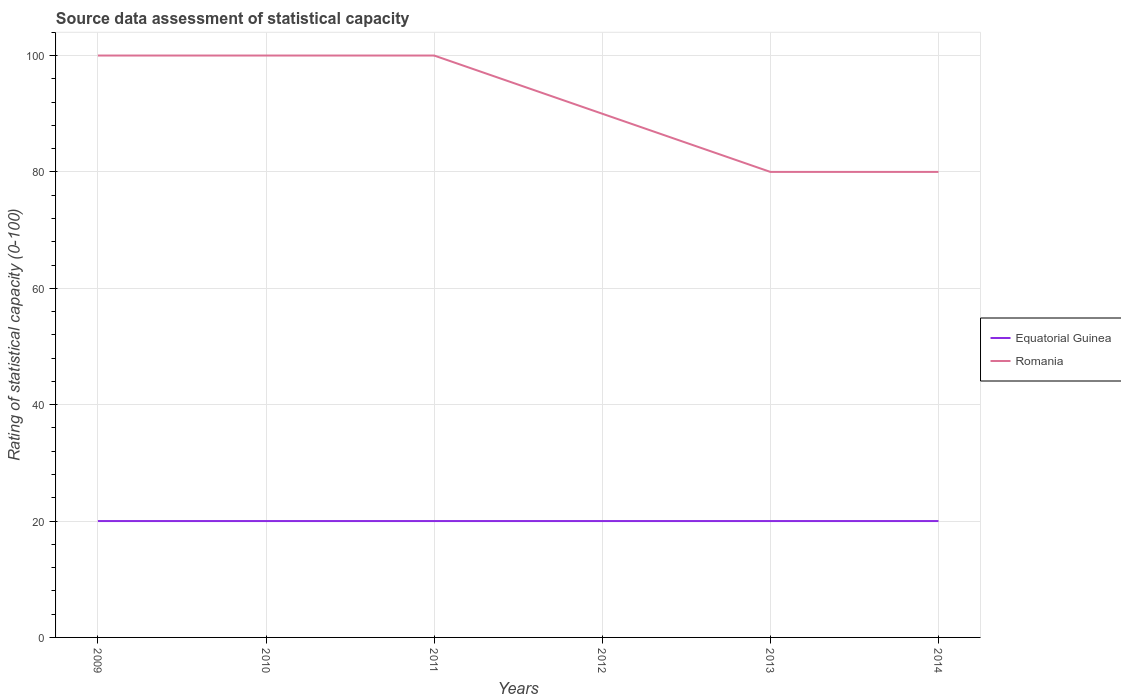How many different coloured lines are there?
Keep it short and to the point. 2. Does the line corresponding to Equatorial Guinea intersect with the line corresponding to Romania?
Your answer should be very brief. No. Is the number of lines equal to the number of legend labels?
Keep it short and to the point. Yes. Across all years, what is the maximum rating of statistical capacity in Romania?
Your response must be concise. 80. In which year was the rating of statistical capacity in Romania maximum?
Provide a succinct answer. 2013. What is the total rating of statistical capacity in Equatorial Guinea in the graph?
Provide a succinct answer. 0. What is the difference between the highest and the second highest rating of statistical capacity in Equatorial Guinea?
Offer a very short reply. 0. How many lines are there?
Provide a succinct answer. 2. What is the difference between two consecutive major ticks on the Y-axis?
Offer a very short reply. 20. Does the graph contain grids?
Offer a very short reply. Yes. Where does the legend appear in the graph?
Offer a terse response. Center right. How are the legend labels stacked?
Offer a terse response. Vertical. What is the title of the graph?
Your response must be concise. Source data assessment of statistical capacity. What is the label or title of the X-axis?
Provide a short and direct response. Years. What is the label or title of the Y-axis?
Give a very brief answer. Rating of statistical capacity (0-100). What is the Rating of statistical capacity (0-100) of Romania in 2009?
Provide a short and direct response. 100. What is the Rating of statistical capacity (0-100) in Equatorial Guinea in 2010?
Your answer should be very brief. 20. What is the Rating of statistical capacity (0-100) of Romania in 2010?
Your response must be concise. 100. What is the Rating of statistical capacity (0-100) of Equatorial Guinea in 2011?
Make the answer very short. 20. What is the Rating of statistical capacity (0-100) in Romania in 2011?
Your answer should be very brief. 100. What is the Rating of statistical capacity (0-100) in Equatorial Guinea in 2014?
Give a very brief answer. 20. What is the total Rating of statistical capacity (0-100) in Equatorial Guinea in the graph?
Offer a terse response. 120. What is the total Rating of statistical capacity (0-100) in Romania in the graph?
Provide a short and direct response. 550. What is the difference between the Rating of statistical capacity (0-100) of Equatorial Guinea in 2009 and that in 2010?
Provide a succinct answer. 0. What is the difference between the Rating of statistical capacity (0-100) of Romania in 2009 and that in 2010?
Provide a short and direct response. 0. What is the difference between the Rating of statistical capacity (0-100) in Equatorial Guinea in 2009 and that in 2013?
Give a very brief answer. 0. What is the difference between the Rating of statistical capacity (0-100) in Romania in 2009 and that in 2013?
Your response must be concise. 20. What is the difference between the Rating of statistical capacity (0-100) of Romania in 2009 and that in 2014?
Offer a very short reply. 20. What is the difference between the Rating of statistical capacity (0-100) of Equatorial Guinea in 2010 and that in 2011?
Make the answer very short. 0. What is the difference between the Rating of statistical capacity (0-100) in Romania in 2010 and that in 2012?
Provide a succinct answer. 10. What is the difference between the Rating of statistical capacity (0-100) of Equatorial Guinea in 2010 and that in 2013?
Your answer should be compact. 0. What is the difference between the Rating of statistical capacity (0-100) of Romania in 2010 and that in 2014?
Keep it short and to the point. 20. What is the difference between the Rating of statistical capacity (0-100) of Equatorial Guinea in 2011 and that in 2012?
Your answer should be very brief. 0. What is the difference between the Rating of statistical capacity (0-100) in Romania in 2011 and that in 2012?
Your answer should be compact. 10. What is the difference between the Rating of statistical capacity (0-100) in Equatorial Guinea in 2011 and that in 2014?
Offer a terse response. 0. What is the difference between the Rating of statistical capacity (0-100) in Equatorial Guinea in 2012 and that in 2013?
Provide a short and direct response. 0. What is the difference between the Rating of statistical capacity (0-100) in Romania in 2013 and that in 2014?
Offer a very short reply. 0. What is the difference between the Rating of statistical capacity (0-100) of Equatorial Guinea in 2009 and the Rating of statistical capacity (0-100) of Romania in 2010?
Offer a very short reply. -80. What is the difference between the Rating of statistical capacity (0-100) of Equatorial Guinea in 2009 and the Rating of statistical capacity (0-100) of Romania in 2011?
Your response must be concise. -80. What is the difference between the Rating of statistical capacity (0-100) in Equatorial Guinea in 2009 and the Rating of statistical capacity (0-100) in Romania in 2012?
Offer a very short reply. -70. What is the difference between the Rating of statistical capacity (0-100) in Equatorial Guinea in 2009 and the Rating of statistical capacity (0-100) in Romania in 2013?
Give a very brief answer. -60. What is the difference between the Rating of statistical capacity (0-100) of Equatorial Guinea in 2009 and the Rating of statistical capacity (0-100) of Romania in 2014?
Give a very brief answer. -60. What is the difference between the Rating of statistical capacity (0-100) of Equatorial Guinea in 2010 and the Rating of statistical capacity (0-100) of Romania in 2011?
Provide a succinct answer. -80. What is the difference between the Rating of statistical capacity (0-100) in Equatorial Guinea in 2010 and the Rating of statistical capacity (0-100) in Romania in 2012?
Your answer should be compact. -70. What is the difference between the Rating of statistical capacity (0-100) of Equatorial Guinea in 2010 and the Rating of statistical capacity (0-100) of Romania in 2013?
Offer a terse response. -60. What is the difference between the Rating of statistical capacity (0-100) in Equatorial Guinea in 2010 and the Rating of statistical capacity (0-100) in Romania in 2014?
Offer a terse response. -60. What is the difference between the Rating of statistical capacity (0-100) of Equatorial Guinea in 2011 and the Rating of statistical capacity (0-100) of Romania in 2012?
Provide a short and direct response. -70. What is the difference between the Rating of statistical capacity (0-100) of Equatorial Guinea in 2011 and the Rating of statistical capacity (0-100) of Romania in 2013?
Your answer should be very brief. -60. What is the difference between the Rating of statistical capacity (0-100) in Equatorial Guinea in 2011 and the Rating of statistical capacity (0-100) in Romania in 2014?
Ensure brevity in your answer.  -60. What is the difference between the Rating of statistical capacity (0-100) of Equatorial Guinea in 2012 and the Rating of statistical capacity (0-100) of Romania in 2013?
Provide a succinct answer. -60. What is the difference between the Rating of statistical capacity (0-100) in Equatorial Guinea in 2012 and the Rating of statistical capacity (0-100) in Romania in 2014?
Keep it short and to the point. -60. What is the difference between the Rating of statistical capacity (0-100) in Equatorial Guinea in 2013 and the Rating of statistical capacity (0-100) in Romania in 2014?
Offer a very short reply. -60. What is the average Rating of statistical capacity (0-100) in Romania per year?
Offer a very short reply. 91.67. In the year 2009, what is the difference between the Rating of statistical capacity (0-100) of Equatorial Guinea and Rating of statistical capacity (0-100) of Romania?
Offer a terse response. -80. In the year 2010, what is the difference between the Rating of statistical capacity (0-100) in Equatorial Guinea and Rating of statistical capacity (0-100) in Romania?
Keep it short and to the point. -80. In the year 2011, what is the difference between the Rating of statistical capacity (0-100) of Equatorial Guinea and Rating of statistical capacity (0-100) of Romania?
Provide a succinct answer. -80. In the year 2012, what is the difference between the Rating of statistical capacity (0-100) of Equatorial Guinea and Rating of statistical capacity (0-100) of Romania?
Provide a short and direct response. -70. In the year 2013, what is the difference between the Rating of statistical capacity (0-100) of Equatorial Guinea and Rating of statistical capacity (0-100) of Romania?
Make the answer very short. -60. In the year 2014, what is the difference between the Rating of statistical capacity (0-100) in Equatorial Guinea and Rating of statistical capacity (0-100) in Romania?
Your answer should be very brief. -60. What is the ratio of the Rating of statistical capacity (0-100) of Equatorial Guinea in 2009 to that in 2010?
Give a very brief answer. 1. What is the ratio of the Rating of statistical capacity (0-100) of Equatorial Guinea in 2009 to that in 2011?
Ensure brevity in your answer.  1. What is the ratio of the Rating of statistical capacity (0-100) in Romania in 2009 to that in 2011?
Provide a short and direct response. 1. What is the ratio of the Rating of statistical capacity (0-100) in Romania in 2009 to that in 2012?
Ensure brevity in your answer.  1.11. What is the ratio of the Rating of statistical capacity (0-100) of Romania in 2009 to that in 2013?
Make the answer very short. 1.25. What is the ratio of the Rating of statistical capacity (0-100) in Romania in 2009 to that in 2014?
Provide a short and direct response. 1.25. What is the ratio of the Rating of statistical capacity (0-100) of Romania in 2010 to that in 2011?
Offer a very short reply. 1. What is the ratio of the Rating of statistical capacity (0-100) in Equatorial Guinea in 2010 to that in 2013?
Give a very brief answer. 1. What is the ratio of the Rating of statistical capacity (0-100) in Romania in 2011 to that in 2012?
Offer a very short reply. 1.11. What is the ratio of the Rating of statistical capacity (0-100) in Romania in 2011 to that in 2013?
Provide a short and direct response. 1.25. What is the ratio of the Rating of statistical capacity (0-100) in Equatorial Guinea in 2011 to that in 2014?
Ensure brevity in your answer.  1. What is the ratio of the Rating of statistical capacity (0-100) of Romania in 2011 to that in 2014?
Provide a short and direct response. 1.25. What is the ratio of the Rating of statistical capacity (0-100) in Romania in 2012 to that in 2014?
Make the answer very short. 1.12. What is the ratio of the Rating of statistical capacity (0-100) of Equatorial Guinea in 2013 to that in 2014?
Provide a succinct answer. 1. What is the difference between the highest and the second highest Rating of statistical capacity (0-100) of Equatorial Guinea?
Your answer should be compact. 0. What is the difference between the highest and the second highest Rating of statistical capacity (0-100) in Romania?
Give a very brief answer. 0. What is the difference between the highest and the lowest Rating of statistical capacity (0-100) in Equatorial Guinea?
Offer a very short reply. 0. What is the difference between the highest and the lowest Rating of statistical capacity (0-100) of Romania?
Keep it short and to the point. 20. 